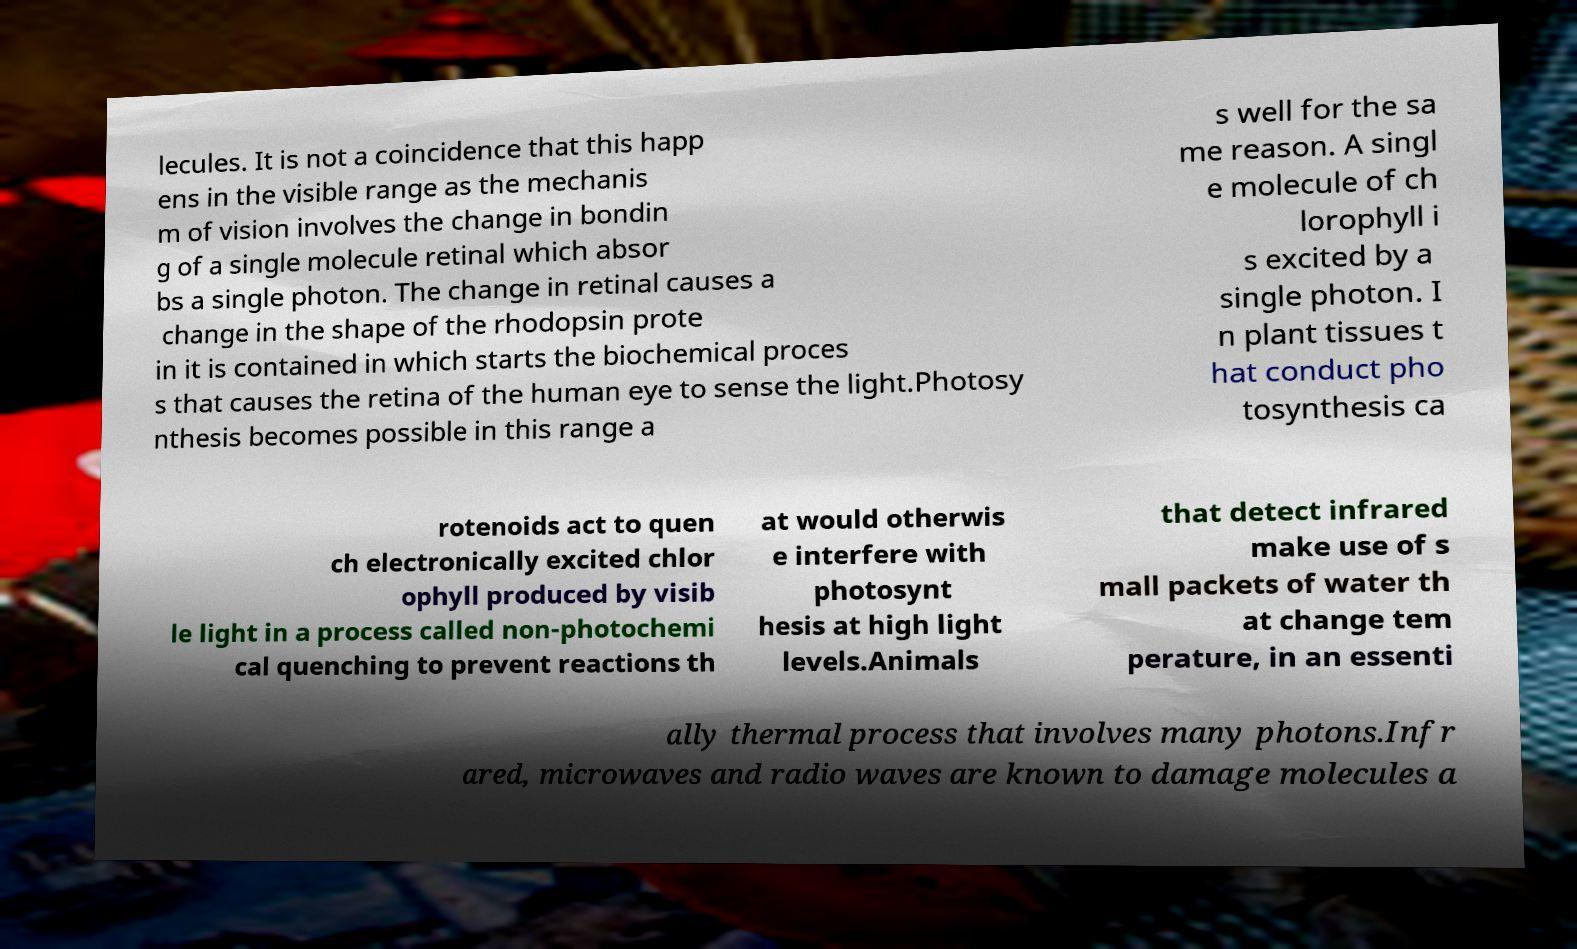Could you assist in decoding the text presented in this image and type it out clearly? lecules. It is not a coincidence that this happ ens in the visible range as the mechanis m of vision involves the change in bondin g of a single molecule retinal which absor bs a single photon. The change in retinal causes a change in the shape of the rhodopsin prote in it is contained in which starts the biochemical proces s that causes the retina of the human eye to sense the light.Photosy nthesis becomes possible in this range a s well for the sa me reason. A singl e molecule of ch lorophyll i s excited by a single photon. I n plant tissues t hat conduct pho tosynthesis ca rotenoids act to quen ch electronically excited chlor ophyll produced by visib le light in a process called non-photochemi cal quenching to prevent reactions th at would otherwis e interfere with photosynt hesis at high light levels.Animals that detect infrared make use of s mall packets of water th at change tem perature, in an essenti ally thermal process that involves many photons.Infr ared, microwaves and radio waves are known to damage molecules a 